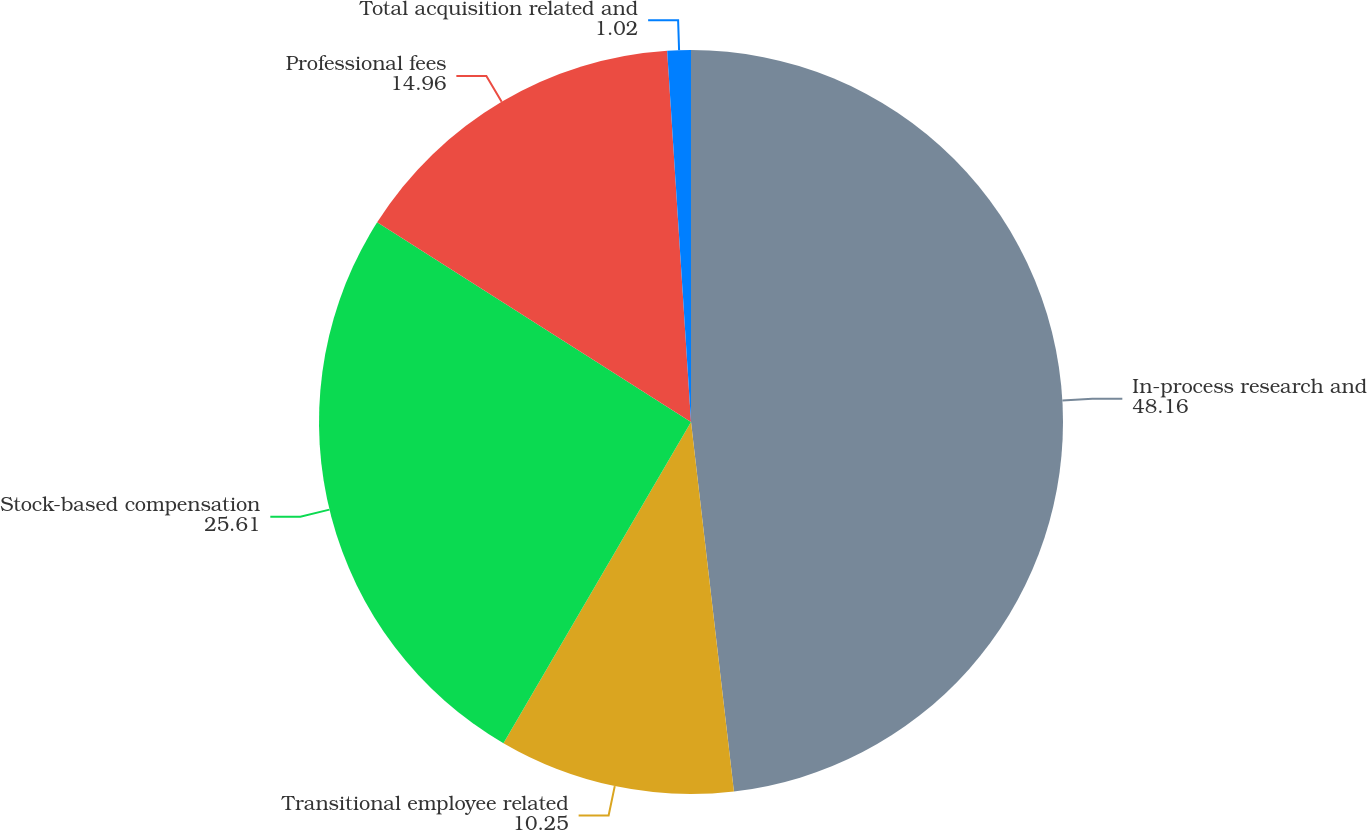Convert chart to OTSL. <chart><loc_0><loc_0><loc_500><loc_500><pie_chart><fcel>In-process research and<fcel>Transitional employee related<fcel>Stock-based compensation<fcel>Professional fees<fcel>Total acquisition related and<nl><fcel>48.16%<fcel>10.25%<fcel>25.61%<fcel>14.96%<fcel>1.02%<nl></chart> 